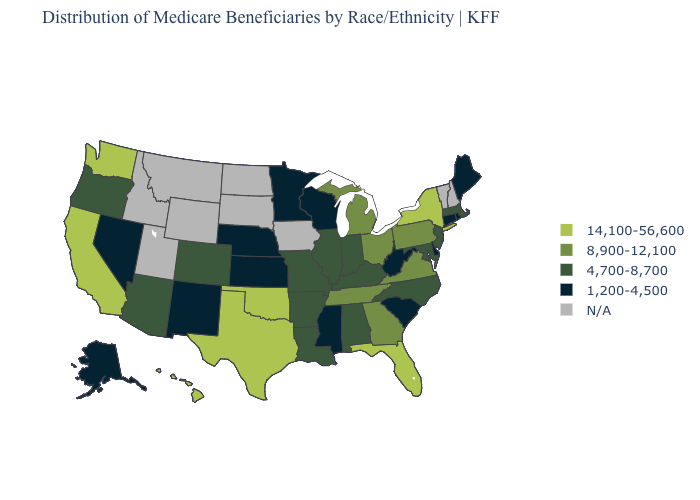What is the value of Washington?
Be succinct. 14,100-56,600. Does Texas have the highest value in the USA?
Write a very short answer. Yes. Name the states that have a value in the range 1,200-4,500?
Concise answer only. Alaska, Connecticut, Delaware, Kansas, Maine, Minnesota, Mississippi, Nebraska, Nevada, New Mexico, Rhode Island, South Carolina, West Virginia, Wisconsin. Does Minnesota have the highest value in the MidWest?
Concise answer only. No. How many symbols are there in the legend?
Give a very brief answer. 5. Is the legend a continuous bar?
Concise answer only. No. What is the value of Wyoming?
Quick response, please. N/A. Does South Carolina have the lowest value in the USA?
Concise answer only. Yes. Which states have the highest value in the USA?
Short answer required. California, Florida, Hawaii, New York, Oklahoma, Texas, Washington. What is the highest value in the South ?
Short answer required. 14,100-56,600. What is the highest value in the USA?
Write a very short answer. 14,100-56,600. Does California have the highest value in the USA?
Give a very brief answer. Yes. What is the highest value in the Northeast ?
Be succinct. 14,100-56,600. Does New Mexico have the lowest value in the West?
Short answer required. Yes. 